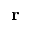<formula> <loc_0><loc_0><loc_500><loc_500>{ r }</formula> 